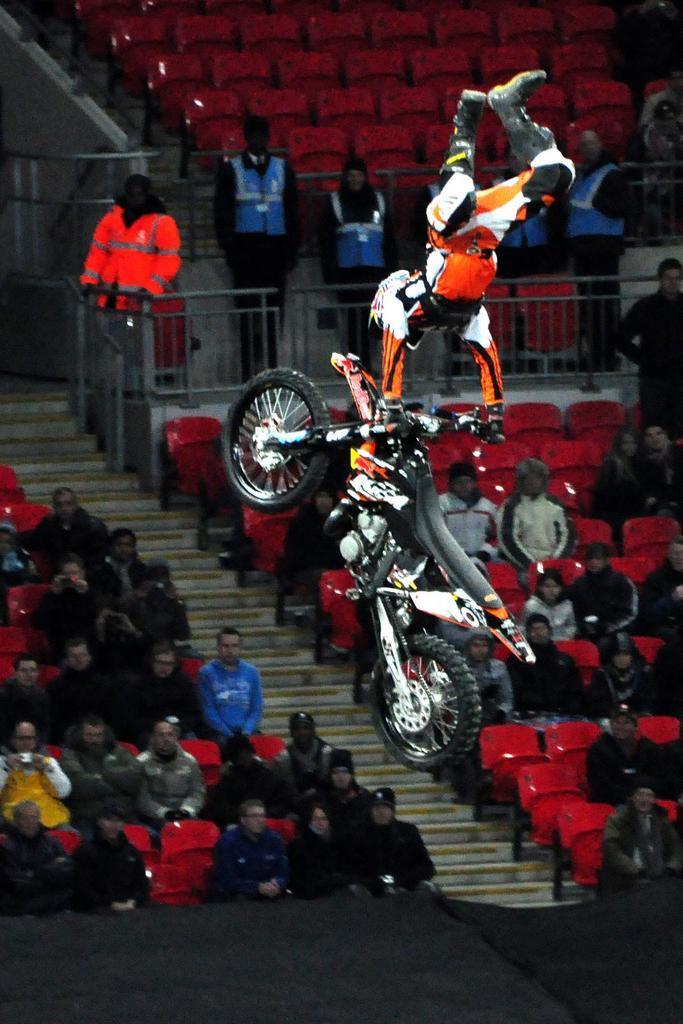Could you give a brief overview of what you see in this image? In this picture we can see a man doing stunt with a motorbike. We can see all the audience sitting on chairs. We can see few persons standing here. 